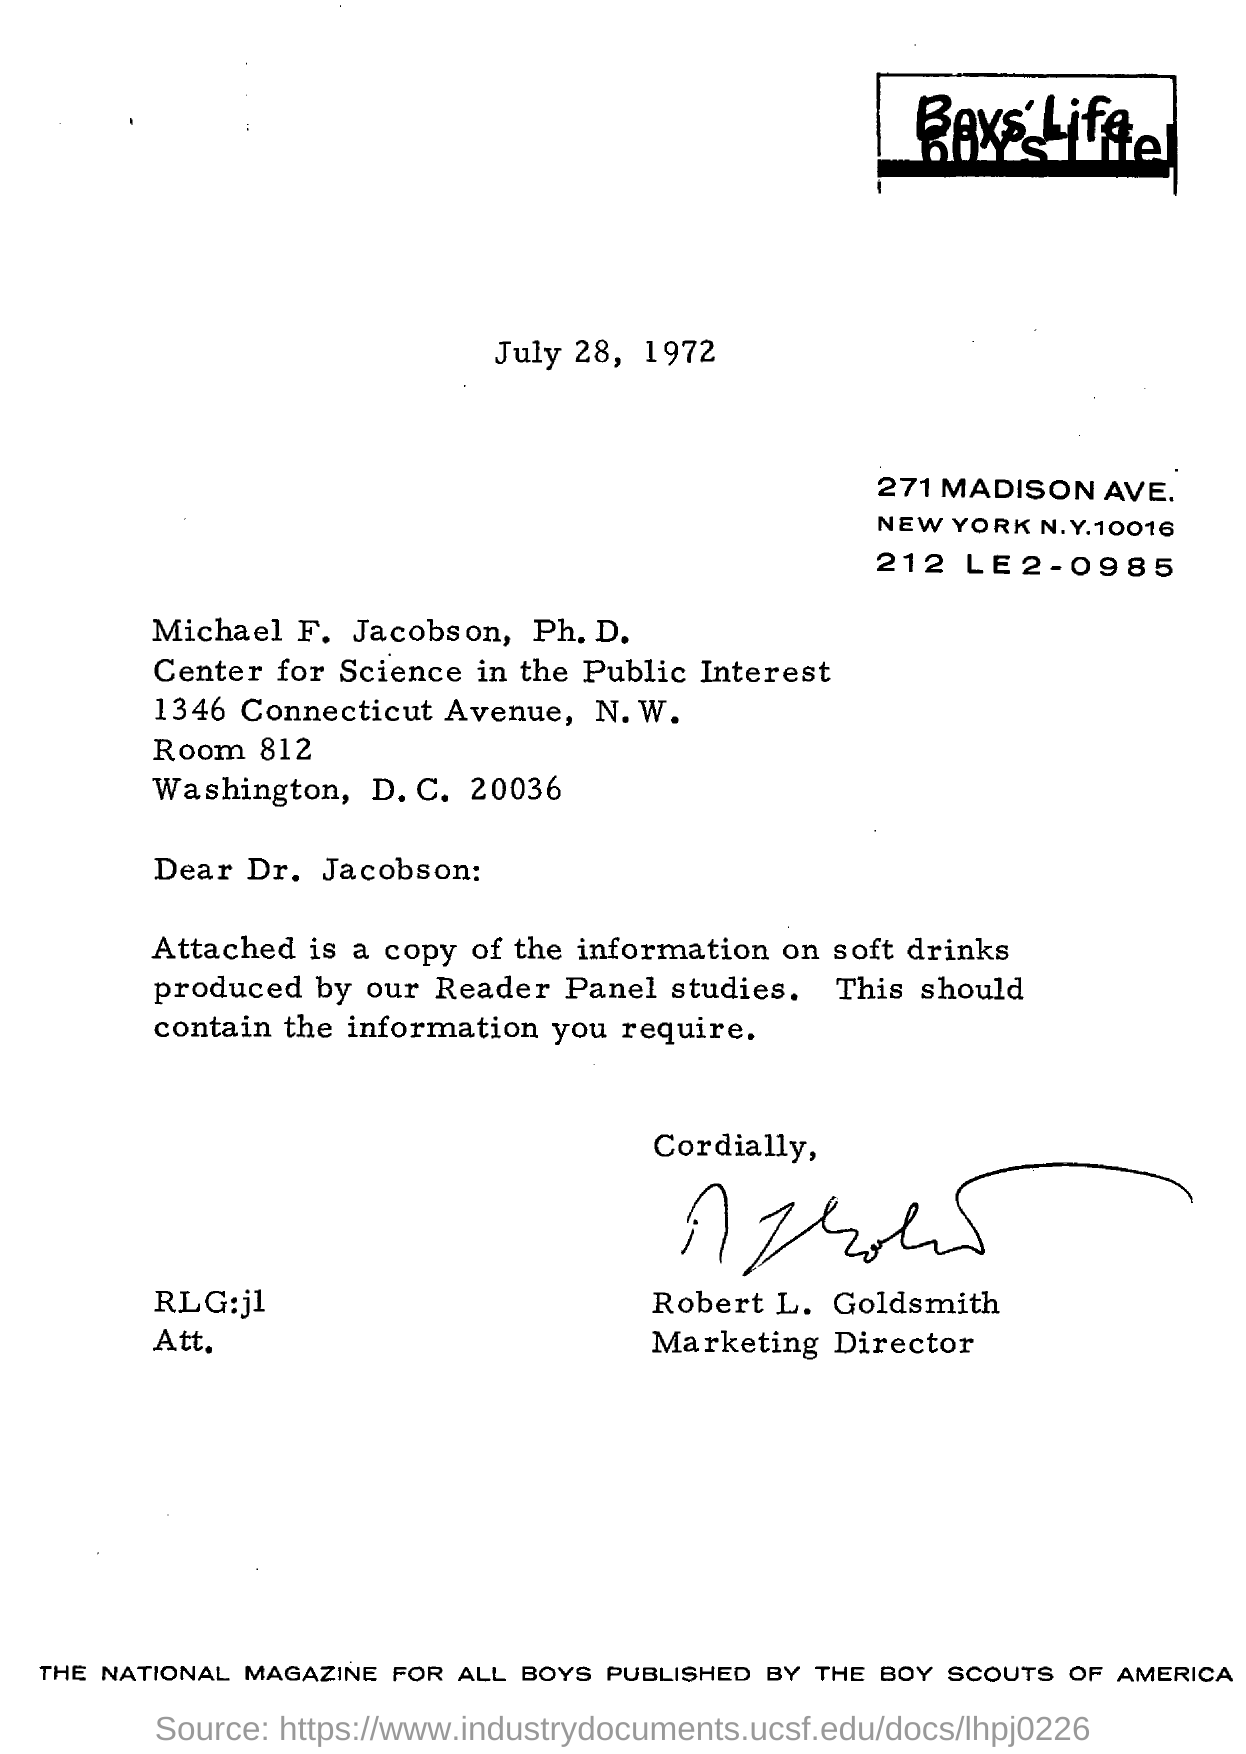Outline some significant characteristics in this image. The date mentioned in the letter is July 28, 1972. Robert L. Goldsmith is the marketing director. The Boy Scouts of America published a national magazine for all boys. 